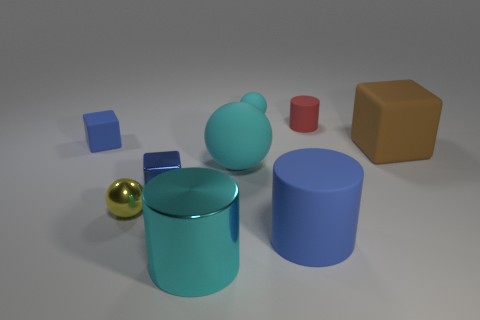Subtract all gray cubes. Subtract all green cylinders. How many cubes are left? 3 Add 1 red matte balls. How many objects exist? 10 Subtract all balls. How many objects are left? 6 Subtract 0 brown spheres. How many objects are left? 9 Subtract all tiny gray metallic spheres. Subtract all tiny yellow shiny spheres. How many objects are left? 8 Add 7 tiny blue shiny things. How many tiny blue shiny things are left? 8 Add 2 tiny red cylinders. How many tiny red cylinders exist? 3 